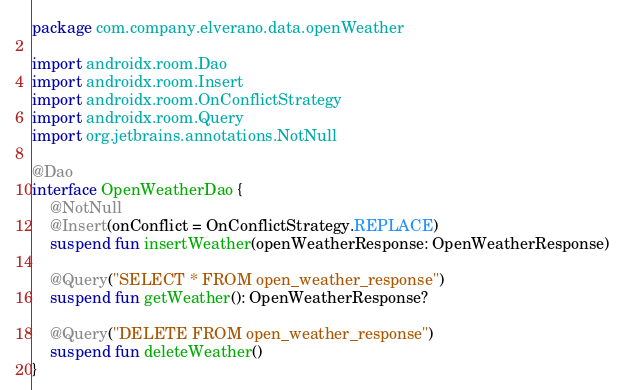Convert code to text. <code><loc_0><loc_0><loc_500><loc_500><_Kotlin_>package com.company.elverano.data.openWeather

import androidx.room.Dao
import androidx.room.Insert
import androidx.room.OnConflictStrategy
import androidx.room.Query
import org.jetbrains.annotations.NotNull

@Dao
interface OpenWeatherDao {
    @NotNull
    @Insert(onConflict = OnConflictStrategy.REPLACE)
    suspend fun insertWeather(openWeatherResponse: OpenWeatherResponse)

    @Query("SELECT * FROM open_weather_response")
    suspend fun getWeather(): OpenWeatherResponse?

    @Query("DELETE FROM open_weather_response")
    suspend fun deleteWeather()
}</code> 